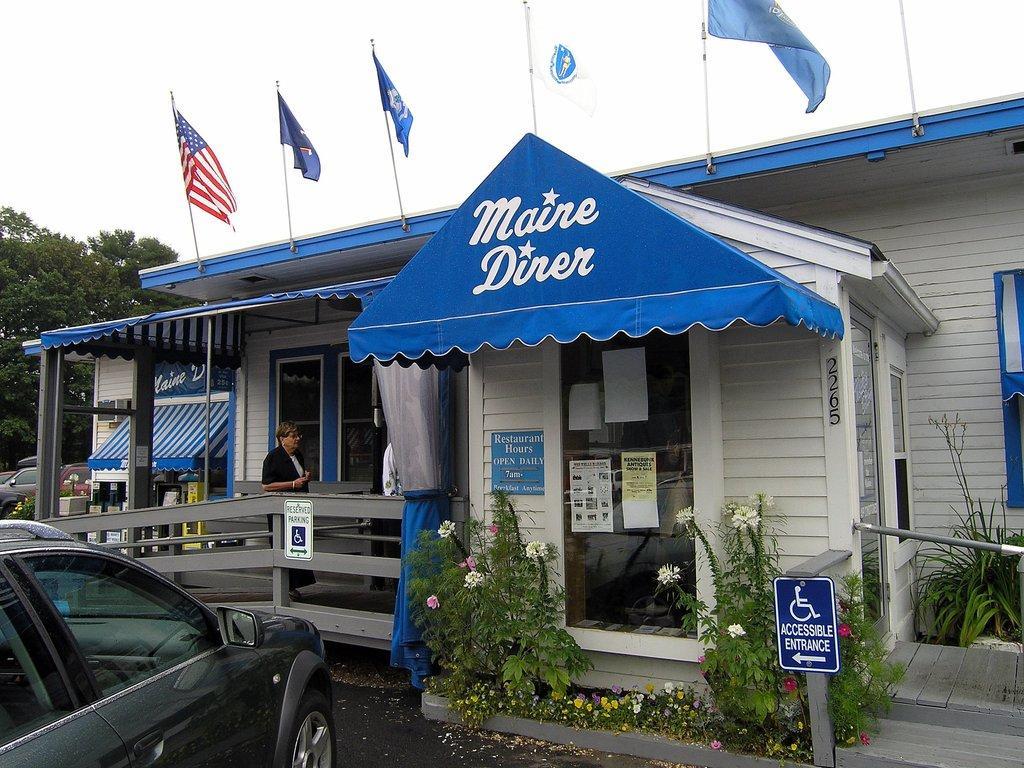Describe this image in one or two sentences. In the image there is a person walking on the floor inside a home with flags above it and plants in front of it with caution board and a car parked on the left side on road, in the back there is a tree and above its sky. 